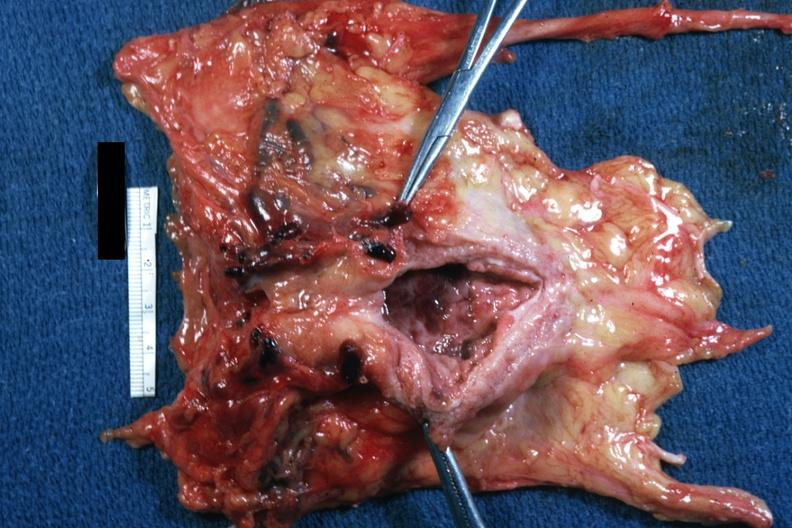s prostate present?
Answer the question using a single word or phrase. Yes 